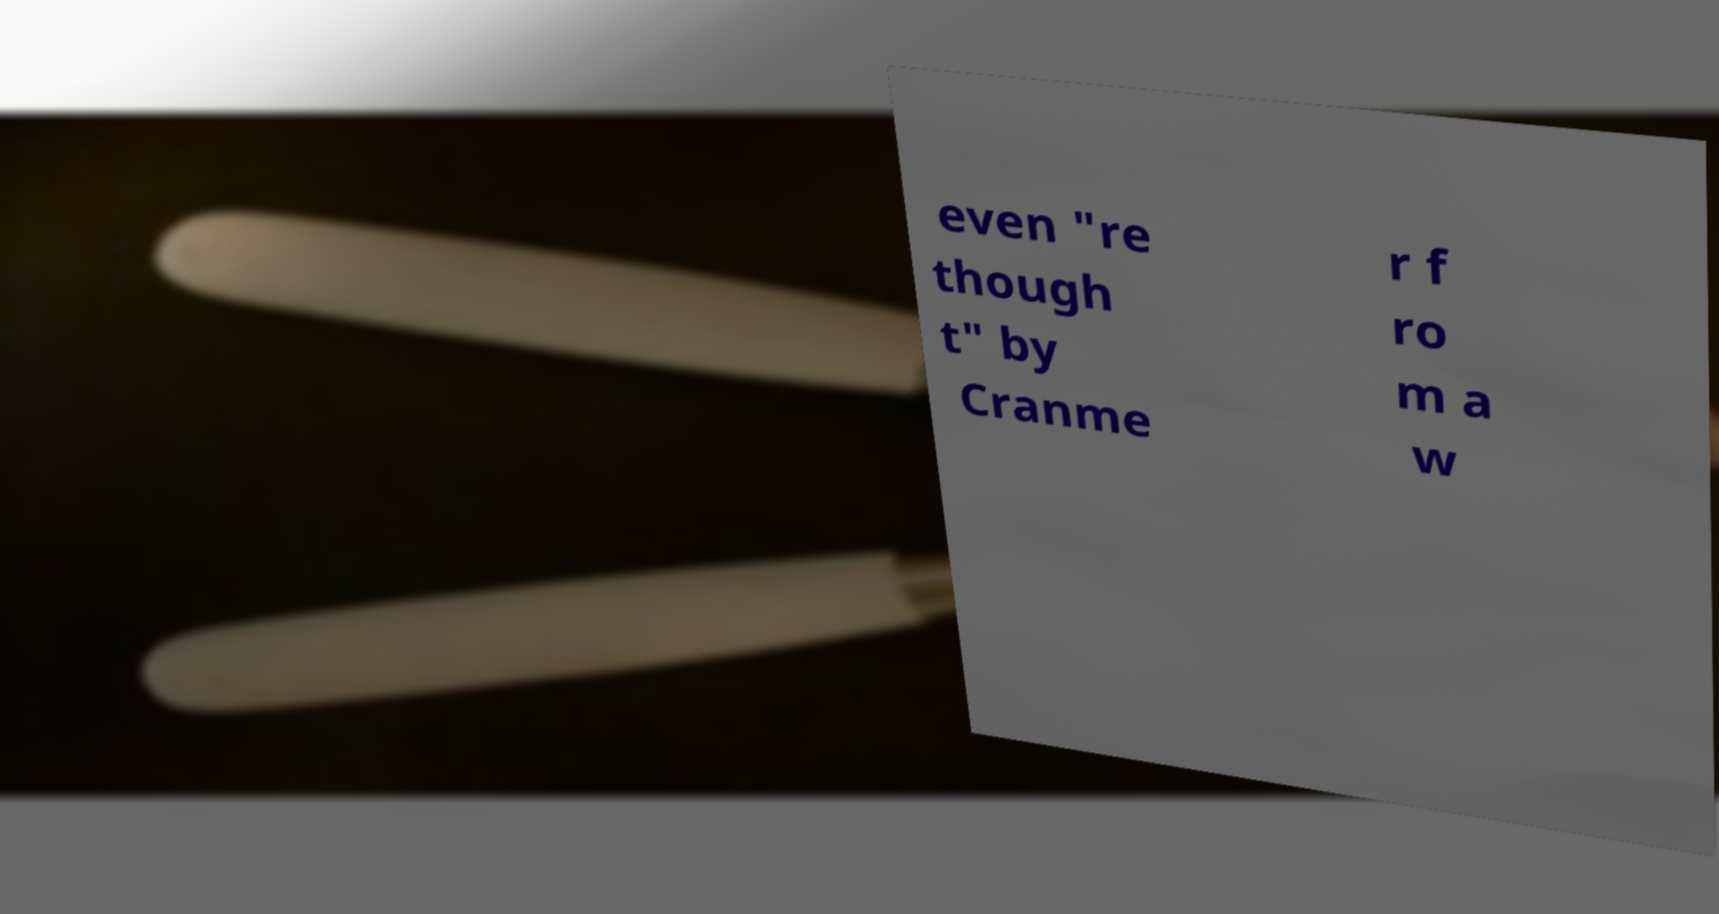Please identify and transcribe the text found in this image. even "re though t" by Cranme r f ro m a w 